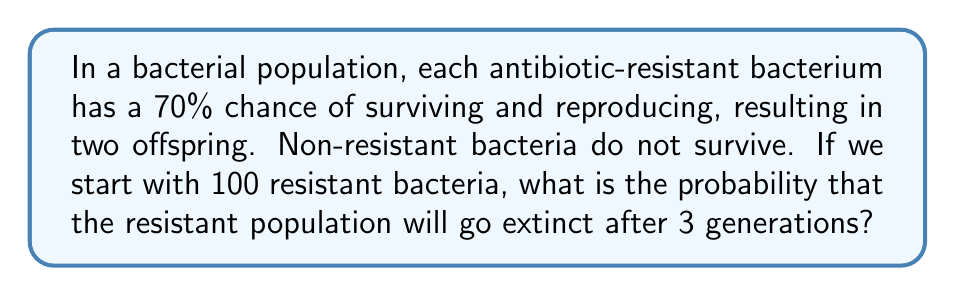Show me your answer to this math problem. Let's approach this step-by-step using a branching process model:

1) Let $p_0$ be the probability of a bacterium producing 0 offspring (extinction), and $p_2$ be the probability of producing 2 offspring (survival and reproduction).

   $p_0 = 0.3$ (30% chance of not surviving)
   $p_2 = 0.7$ (70% chance of surviving and reproducing)

2) The probability generating function (PGF) for this process is:
   
   $f(s) = p_0 + p_2s^2 = 0.3 + 0.7s^2$

3) To find the probability of extinction after 3 generations, we need to compose this function with itself 3 times:

   $f_3(s) = f(f(f(s)))$

4) Let's calculate this step by step:
   
   $f_2(s) = f(f(s)) = 0.3 + 0.7(0.3 + 0.7s^2)^2$
   $         = 0.3 + 0.7(0.09 + 0.42s^2 + 0.49s^4)$
   $         = 0.363 + 0.294s^2 + 0.343s^4$

   $f_3(s) = f(f_2(s)) = 0.3 + 0.7(0.363 + 0.294s^2 + 0.343s^4)^2$

5) The probability of extinction for a single bacterium after 3 generations is $f_3(0)$:

   $f_3(0) = 0.3 + 0.7(0.363)^2 = 0.3 + 0.7(0.131769) = 0.392238$

6) For 100 independent bacteria, the probability that all of them go extinct is:

   $(0.392238)^{100} \approx 1.0668 \times 10^{-43}$

7) Therefore, the probability that the resistant population will go extinct after 3 generations is approximately $1.0668 \times 10^{-43}$.
Answer: $1.0668 \times 10^{-43}$ 